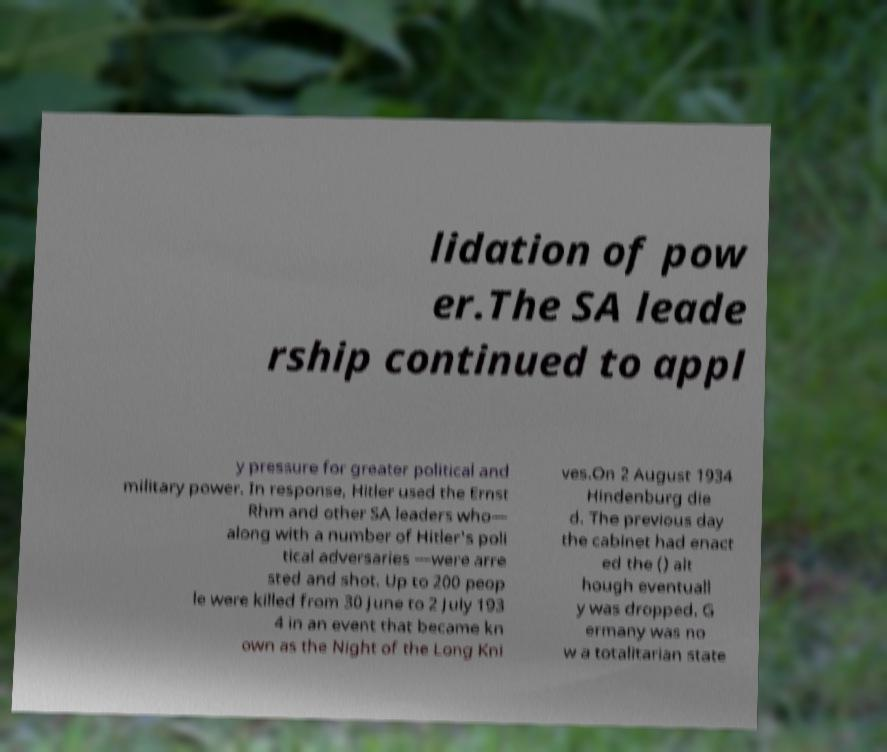For documentation purposes, I need the text within this image transcribed. Could you provide that? lidation of pow er.The SA leade rship continued to appl y pressure for greater political and military power. In response, Hitler used the Ernst Rhm and other SA leaders who— along with a number of Hitler's poli tical adversaries —were arre sted and shot. Up to 200 peop le were killed from 30 June to 2 July 193 4 in an event that became kn own as the Night of the Long Kni ves.On 2 August 1934 Hindenburg die d. The previous day the cabinet had enact ed the () alt hough eventuall y was dropped. G ermany was no w a totalitarian state 